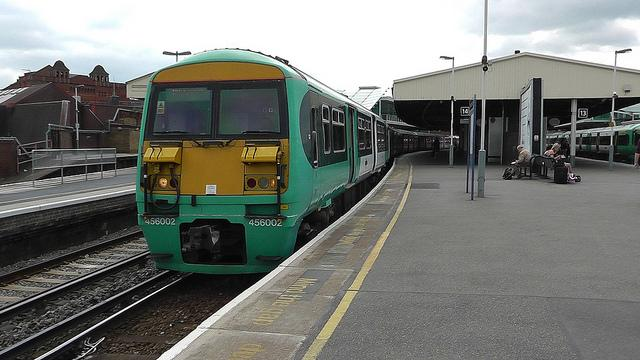What are the people on the bench doing?

Choices:
A) working
B) sleeping
C) gaming
D) waiting waiting 